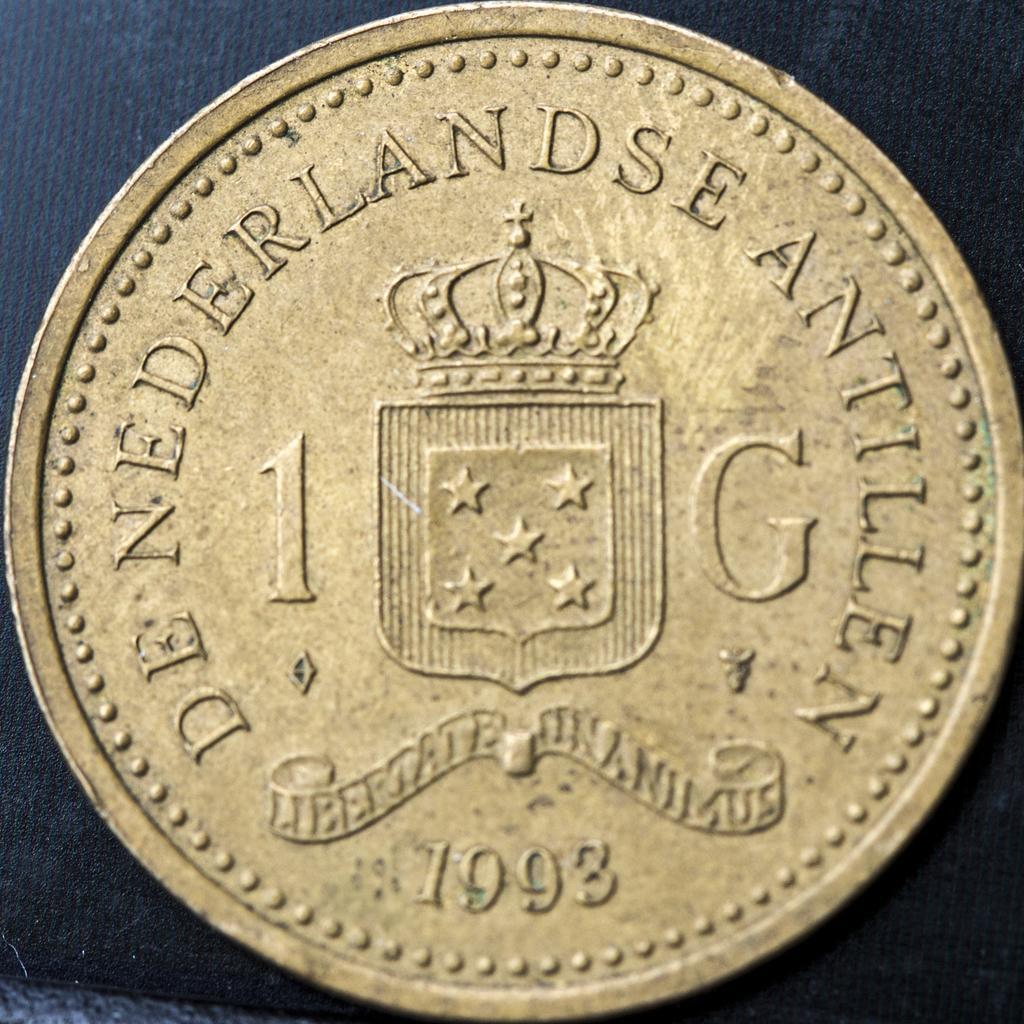<image>
Provide a brief description of the given image. 1993 coin from de nederlandse antillen for 1 g 